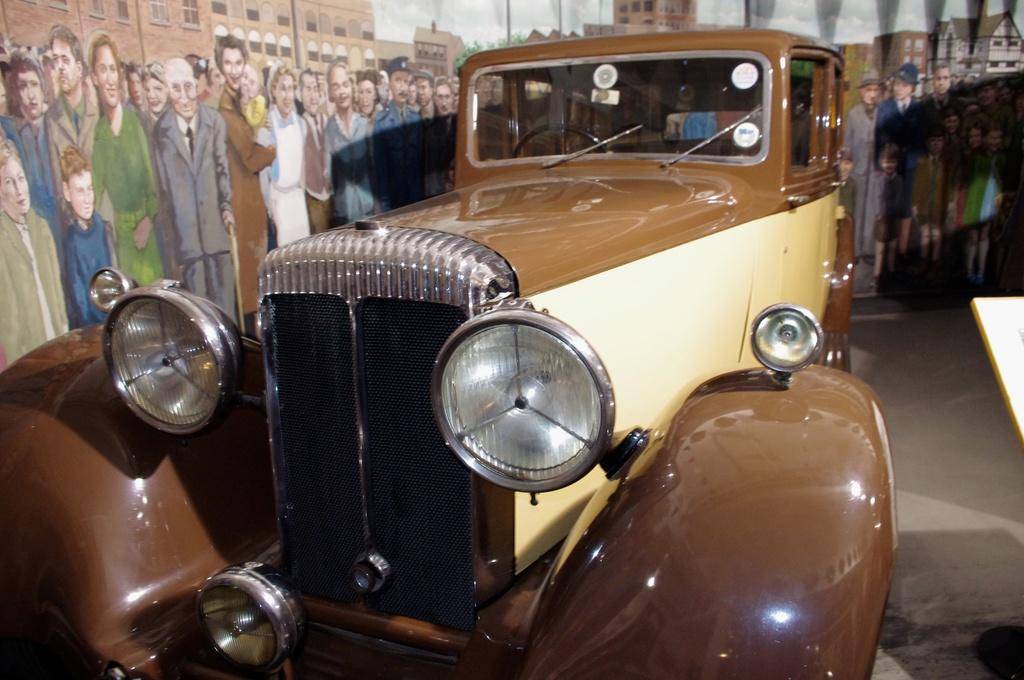What is the main subject of the image? There is a car in the image. What can be seen in the background of the image? There are buildings and a group of people in the background of the image. What type of hose is connected to the car in the image? There is no hose connected to the car in the image. How many cups are visible on the car's dashboard in the image? There are no cups visible on the car's dashboard in the image. 